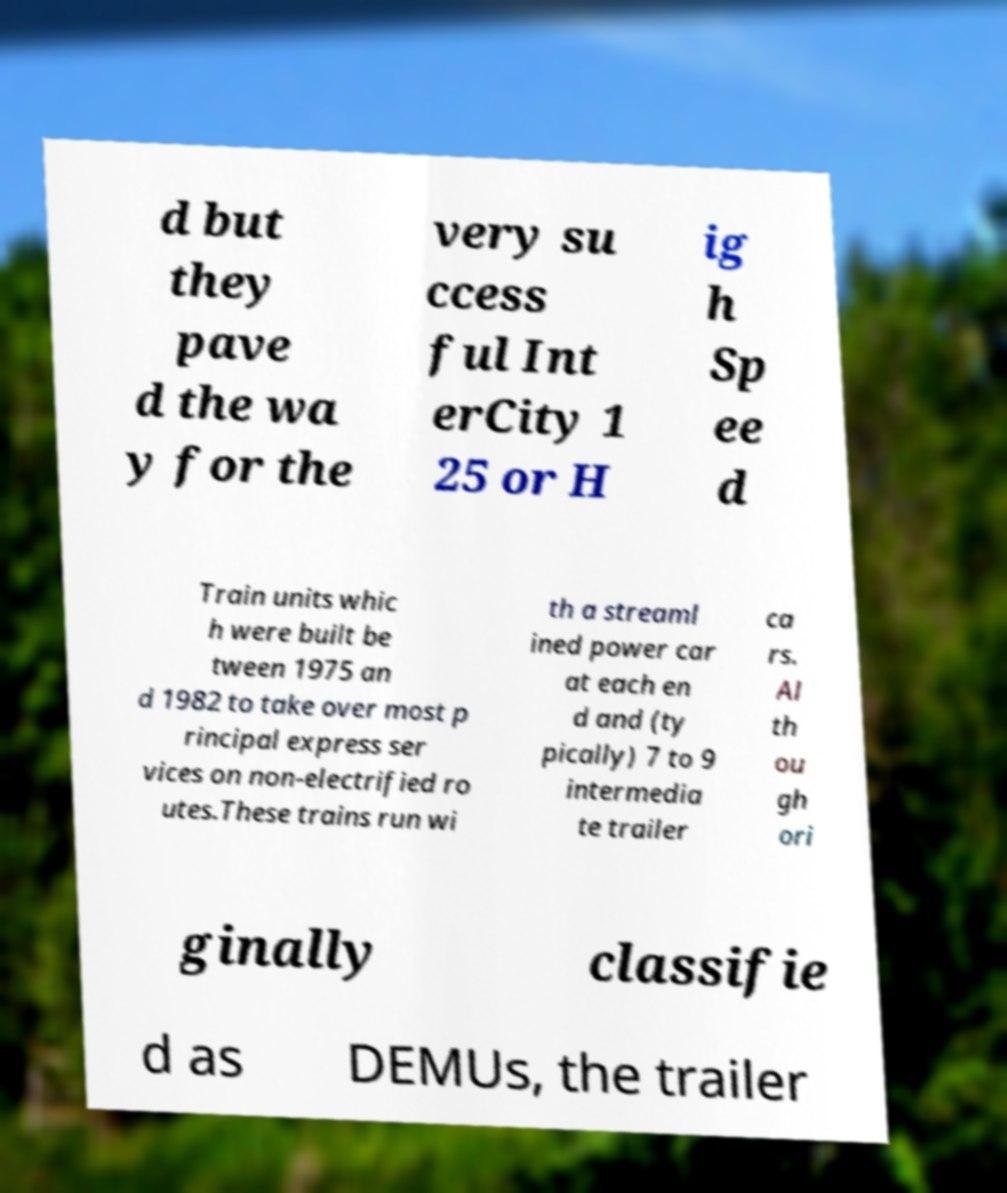What messages or text are displayed in this image? I need them in a readable, typed format. d but they pave d the wa y for the very su ccess ful Int erCity 1 25 or H ig h Sp ee d Train units whic h were built be tween 1975 an d 1982 to take over most p rincipal express ser vices on non-electrified ro utes.These trains run wi th a streaml ined power car at each en d and (ty pically) 7 to 9 intermedia te trailer ca rs. Al th ou gh ori ginally classifie d as DEMUs, the trailer 